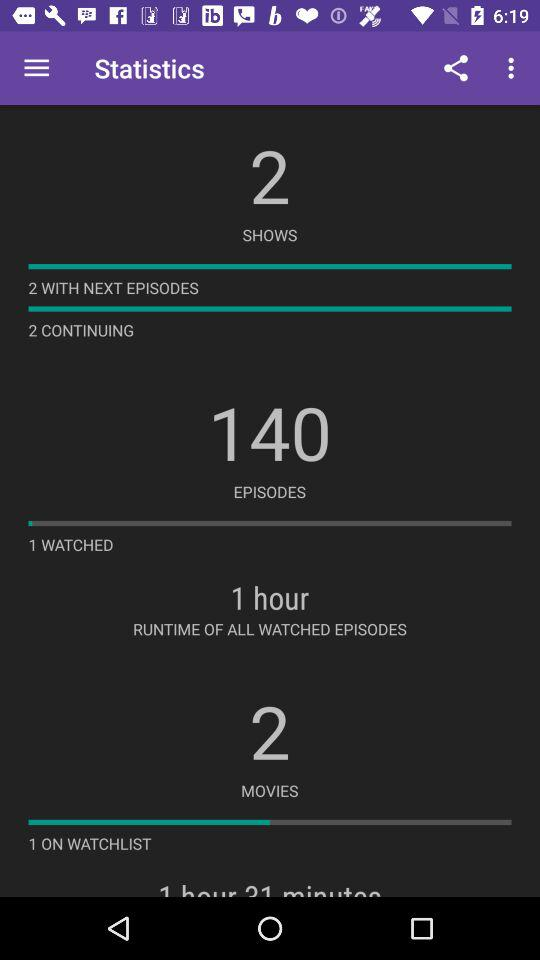How many movies are on watchlist? There is 1 movie on watchlist. 